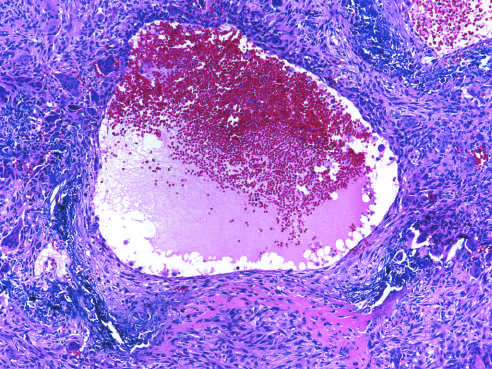how is aneurysmal bone cyst with blood-filled cystic space surrounded?
Answer the question using a single word or phrase. By a fibrous wall containing proliferating fibroblasts 